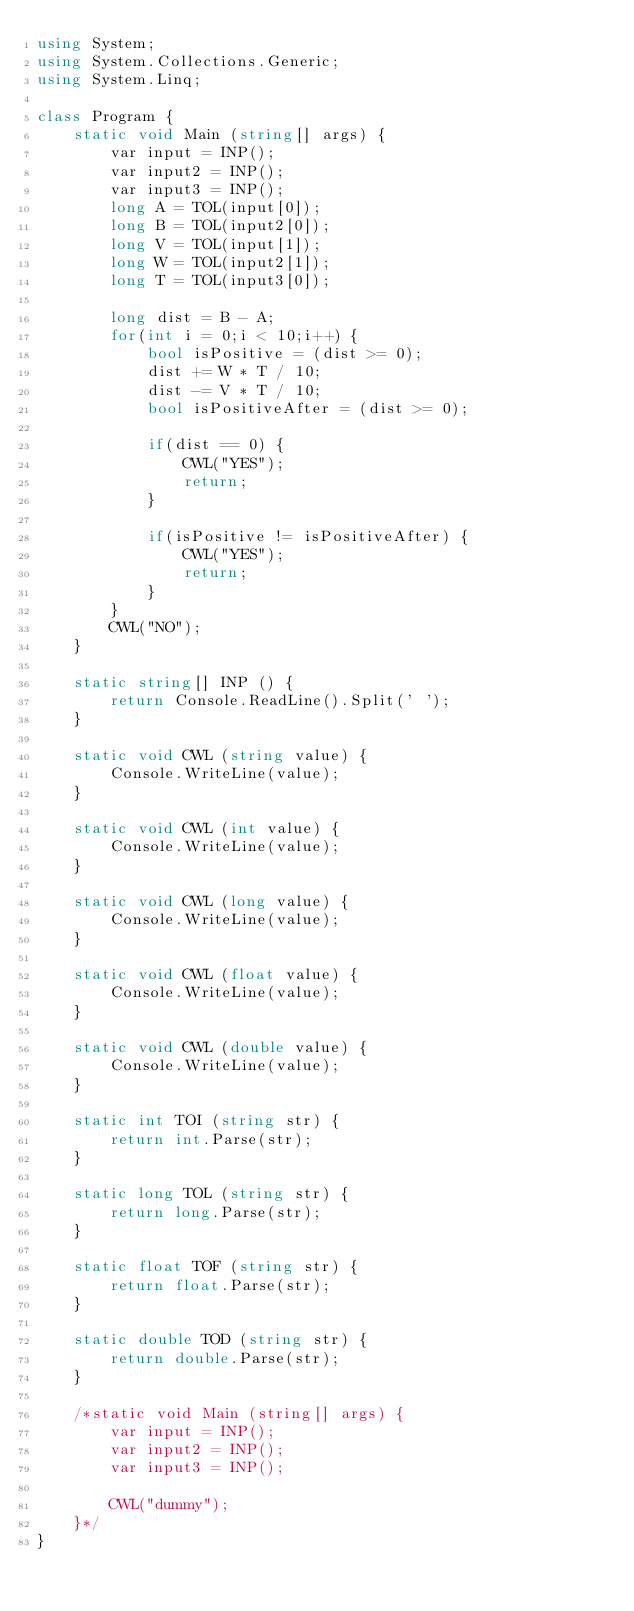Convert code to text. <code><loc_0><loc_0><loc_500><loc_500><_C#_>using System;
using System.Collections.Generic;
using System.Linq;

class Program {
    static void Main (string[] args) {
        var input = INP();
        var input2 = INP();
        var input3 = INP();
        long A = TOL(input[0]);
        long B = TOL(input2[0]);
        long V = TOL(input[1]);
        long W = TOL(input2[1]);
        long T = TOL(input3[0]);

        long dist = B - A;
        for(int i = 0;i < 10;i++) {
            bool isPositive = (dist >= 0);
            dist += W * T / 10;
            dist -= V * T / 10;
            bool isPositiveAfter = (dist >= 0);

            if(dist == 0) {
                CWL("YES");
                return;
            }

            if(isPositive != isPositiveAfter) {
                CWL("YES");
                return;
            }
        }
        CWL("NO");
    }

    static string[] INP () {
        return Console.ReadLine().Split(' ');
    }

    static void CWL (string value) {
        Console.WriteLine(value);
    }

    static void CWL (int value) {
        Console.WriteLine(value);
    }

    static void CWL (long value) {
        Console.WriteLine(value);
    }

    static void CWL (float value) {
        Console.WriteLine(value);
    }

    static void CWL (double value) {
        Console.WriteLine(value);
    }

    static int TOI (string str) {
        return int.Parse(str);
    }

    static long TOL (string str) {
        return long.Parse(str);
    }

    static float TOF (string str) {
        return float.Parse(str);
    }

    static double TOD (string str) {
        return double.Parse(str);
    }

    /*static void Main (string[] args) {
        var input = INP();
        var input2 = INP();
        var input3 = INP();

        CWL("dummy");
    }*/
}
</code> 